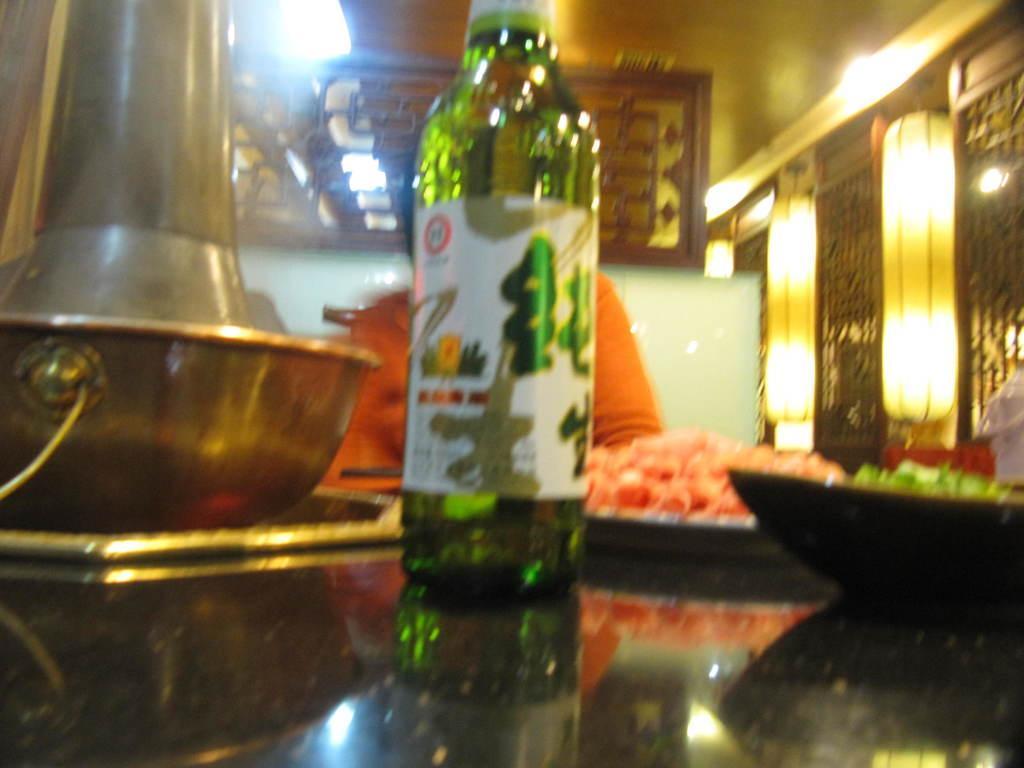In one or two sentences, can you explain what this image depicts? In this picture there is a glass bottle and food eatables on top of a table. In the background we observe designed photo frames and wall. 